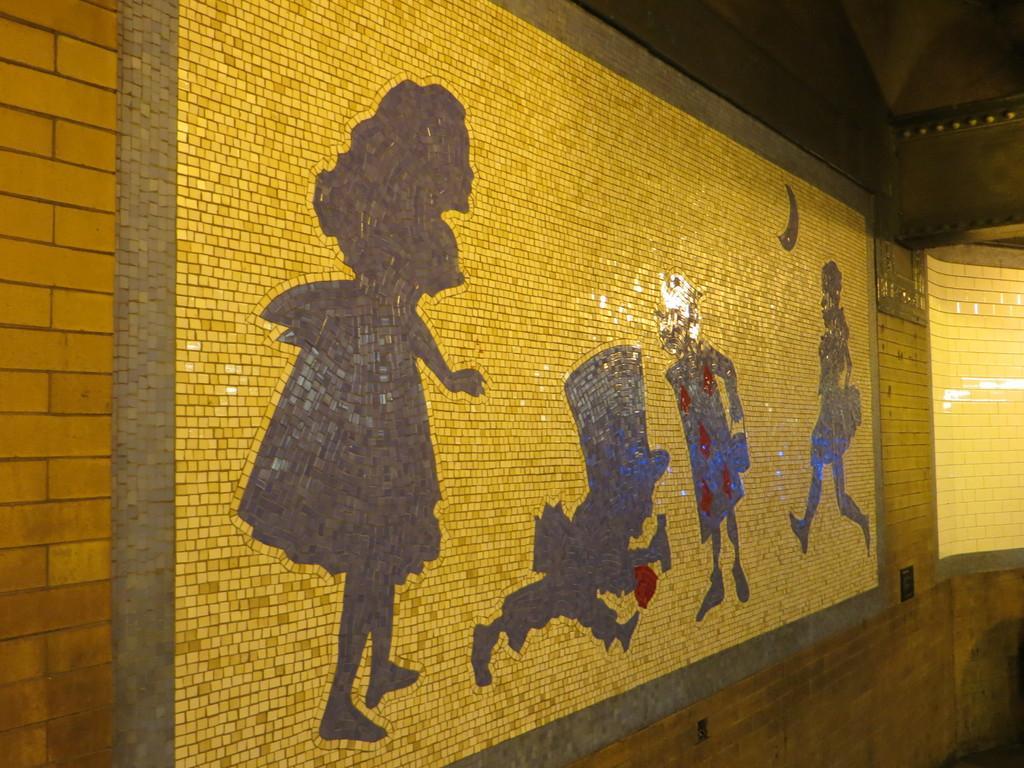How would you summarize this image in a sentence or two? In this image, there is wall contains an art. 